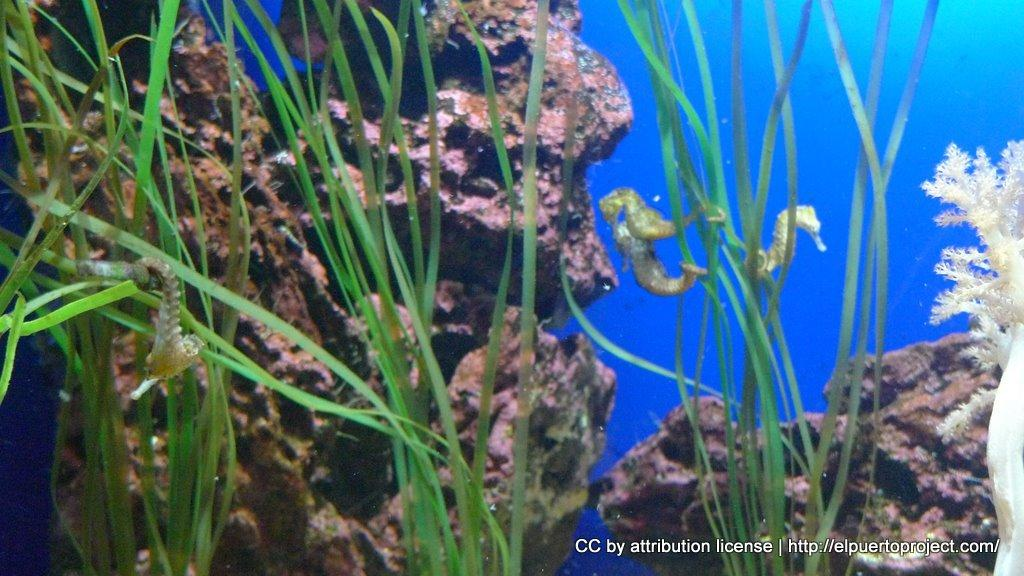What type of animals are in the image? There are seahorses in the image. Where are the seahorses located? The seahorses are underwater. What other elements can be seen in the underwater environment? There are water-plants and stones in the image. What type of toothpaste is being used by the seahorses in the image? There is no toothpaste present in the image, as it features seahorses underwater with water-plants and stones. 